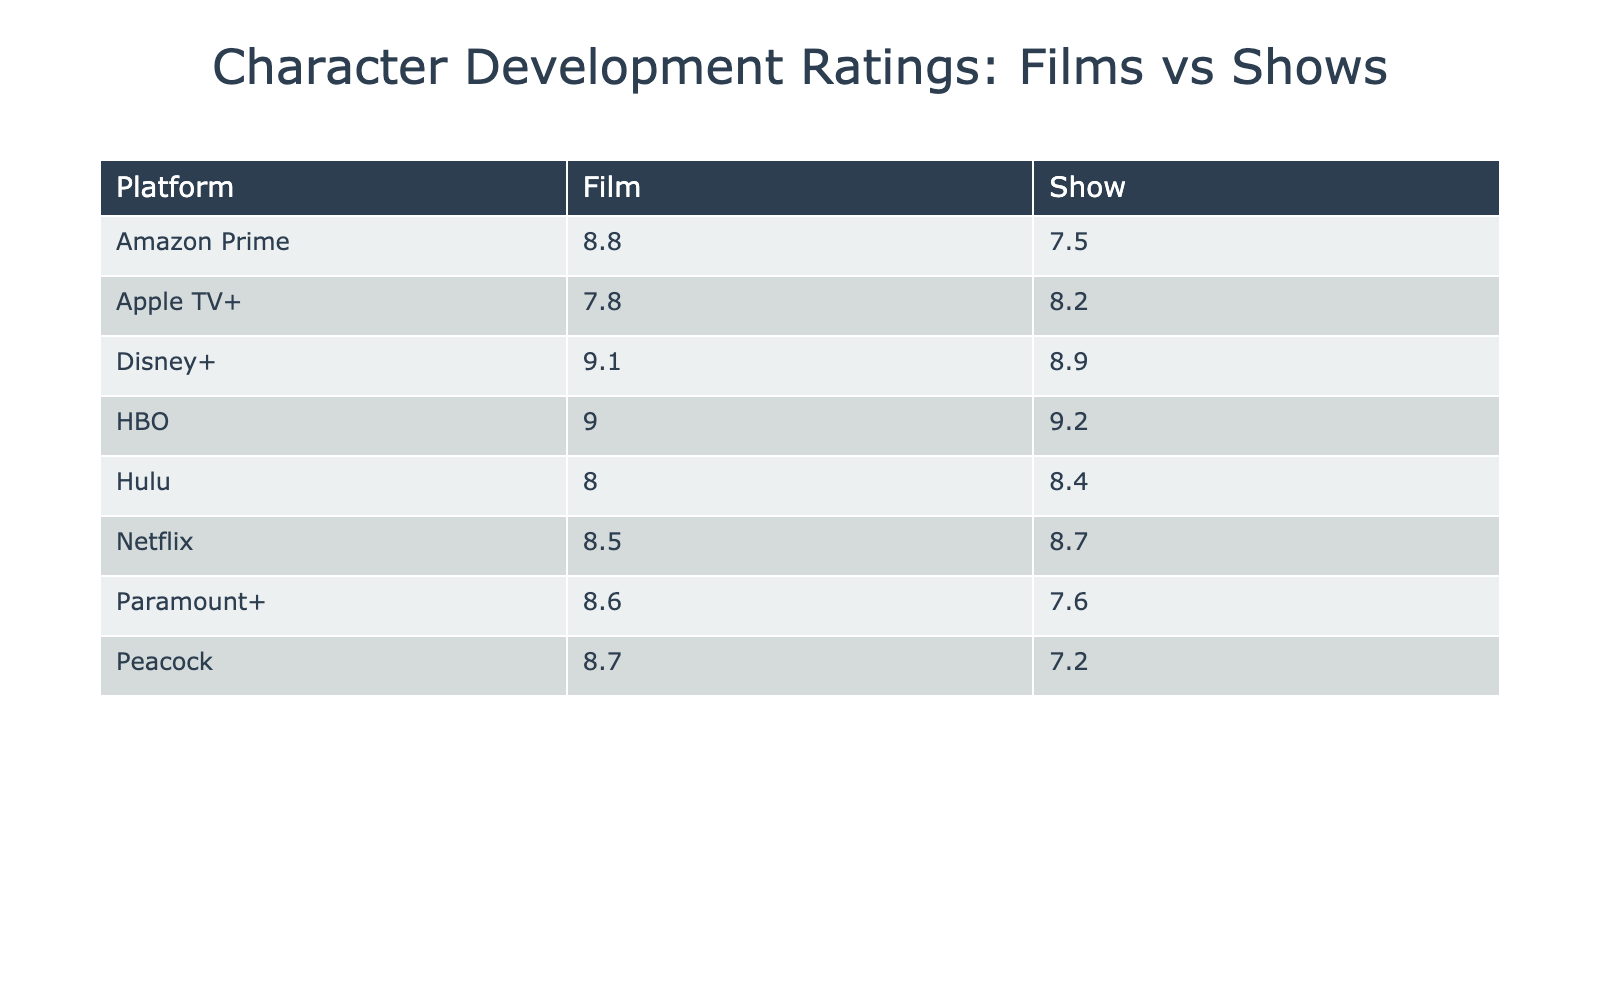What is the highest-rated film in the table? Among the films listed, "Manchester by the Sea" has the highest Average Character Development Rating of 9.0.
Answer: Manchester by the Sea Which show has the lowest character development rating on the table? The show with the lowest rating is "Psych 2: Lassie Come Home" at 7.2.
Answer: Psych 2: Lassie Come Home What is the average character development rating for films across all platforms? The films have the ratings: 8.5, 9.0, 8.8, 9.1, 7.8, 8.0, 8.6, 8.7. The total sum is 70.5, and there are 8 films, so the average is 70.5 / 8 = 8.8125.
Answer: 8.81 Is the average character development rating of shows higher than that of films? The average rating for shows is 8.55, while for films, it is 8.81, meaning that films have a higher average rating than shows.
Answer: No Which platform has the highest average rating for shows? The "HBO" show "Succession" has the highest rating at 9.2, making HBO the platform with the highest show rating.
Answer: HBO What is the difference in character development ratings between the highest film and the lowest show? The highest film rating is 9.2 ("Succession"), and the lowest show rating is 7.2 ("Psych 2: Lassie Come Home"). The difference is 9.2 - 7.2 = 2.0.
Answer: 2.0 Which platform has the highest average character development rating across both films and shows? To find this, compare the average ratings for each platform: Netflix = (8.5 + 8.7)/2 = 8.6, HBO = (9.0 + 9.2)/2 = 9.1, Amazon Prime = (8.8 + 7.5)/2 = 8.15, Disney+ = (9.1 + 8.9)/2 = 9.0, Apple TV+ = (7.8 + 8.2)/2 = 8.0, Hulu = (8.0 + 8.4)/2 = 8.2, Paramount+ = (8.6 + 7.6)/2 = 8.1, Peacock = (8.7 + 7.2)/2 = 7.95. The highest average is HBO with 9.1.
Answer: HBO What is the total character development rating for all films listed in the table? The ratings summed up are 8.5 + 9.0 + 8.8 + 9.1 + 7.8 + 8.0 + 8.6 + 8.7 = 70.5.
Answer: 70.5 How many platforms have at least one show rated above 8.0? The platforms with shows above 8.0 are Netflix, HBO, Disney+, Hulu, and Apple TV+. That makes 5 platforms.
Answer: 5 Is there a film on Disney+ that has a higher rating than "The Crown"? "The Crown" has a rating of 8.7; the film "Black Panther" on Disney+ has a rating of 9.1, which is higher than "The Crown."
Answer: Yes 